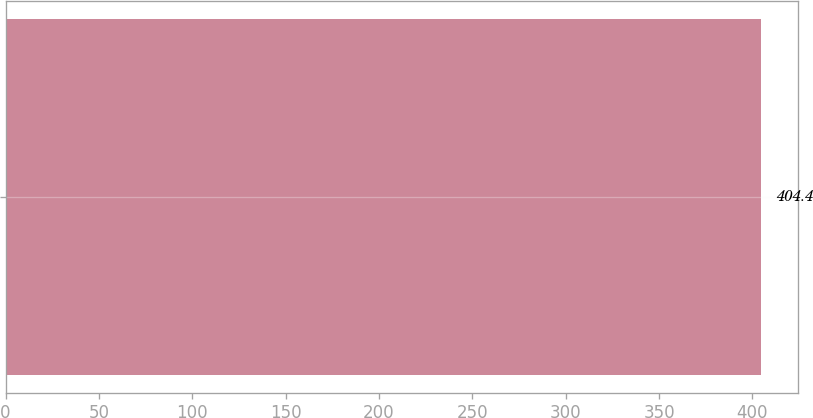<chart> <loc_0><loc_0><loc_500><loc_500><bar_chart><ecel><nl><fcel>404.4<nl></chart> 